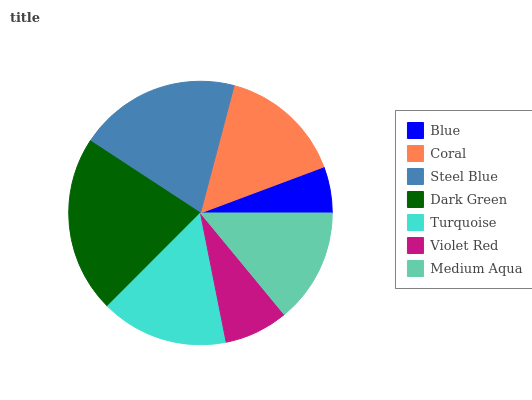Is Blue the minimum?
Answer yes or no. Yes. Is Dark Green the maximum?
Answer yes or no. Yes. Is Coral the minimum?
Answer yes or no. No. Is Coral the maximum?
Answer yes or no. No. Is Coral greater than Blue?
Answer yes or no. Yes. Is Blue less than Coral?
Answer yes or no. Yes. Is Blue greater than Coral?
Answer yes or no. No. Is Coral less than Blue?
Answer yes or no. No. Is Coral the high median?
Answer yes or no. Yes. Is Coral the low median?
Answer yes or no. Yes. Is Medium Aqua the high median?
Answer yes or no. No. Is Violet Red the low median?
Answer yes or no. No. 